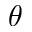Convert formula to latex. <formula><loc_0><loc_0><loc_500><loc_500>\theta</formula> 